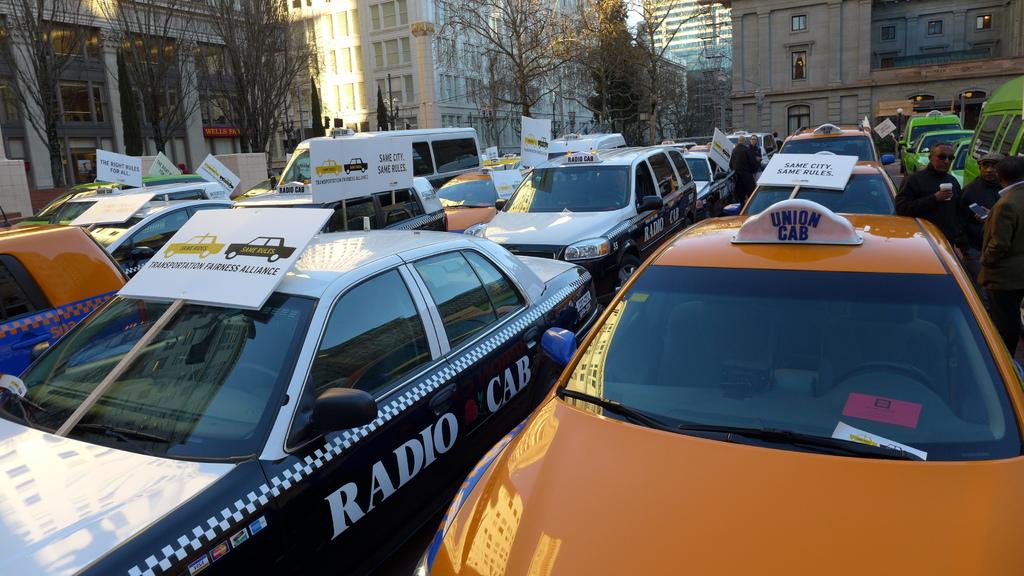What is written on the left car?
Provide a succinct answer. Radio cab. What type of cab is the yellow cab?
Your answer should be compact. Union. 